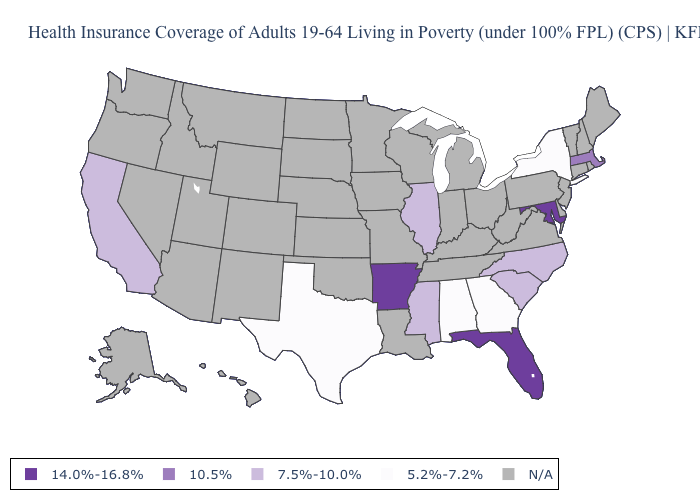What is the value of Indiana?
Give a very brief answer. N/A. Name the states that have a value in the range 7.5%-10.0%?
Answer briefly. California, Illinois, Mississippi, North Carolina, South Carolina. Name the states that have a value in the range N/A?
Write a very short answer. Alaska, Arizona, Colorado, Connecticut, Delaware, Hawaii, Idaho, Indiana, Iowa, Kansas, Kentucky, Louisiana, Maine, Michigan, Minnesota, Missouri, Montana, Nebraska, Nevada, New Hampshire, New Jersey, New Mexico, North Dakota, Ohio, Oklahoma, Oregon, Pennsylvania, Rhode Island, South Dakota, Tennessee, Utah, Vermont, Virginia, Washington, West Virginia, Wisconsin, Wyoming. What is the value of Louisiana?
Short answer required. N/A. Does New York have the lowest value in the USA?
Quick response, please. Yes. What is the value of Idaho?
Keep it brief. N/A. Name the states that have a value in the range 14.0%-16.8%?
Quick response, please. Arkansas, Florida, Maryland. Name the states that have a value in the range 10.5%?
Short answer required. Massachusetts. Among the states that border New Hampshire , which have the highest value?
Short answer required. Massachusetts. Among the states that border South Carolina , does Georgia have the highest value?
Short answer required. No. Which states hav the highest value in the South?
Quick response, please. Arkansas, Florida, Maryland. Name the states that have a value in the range 5.2%-7.2%?
Write a very short answer. Alabama, Georgia, New York, Texas. What is the highest value in the Northeast ?
Short answer required. 10.5%. Name the states that have a value in the range 5.2%-7.2%?
Be succinct. Alabama, Georgia, New York, Texas. 